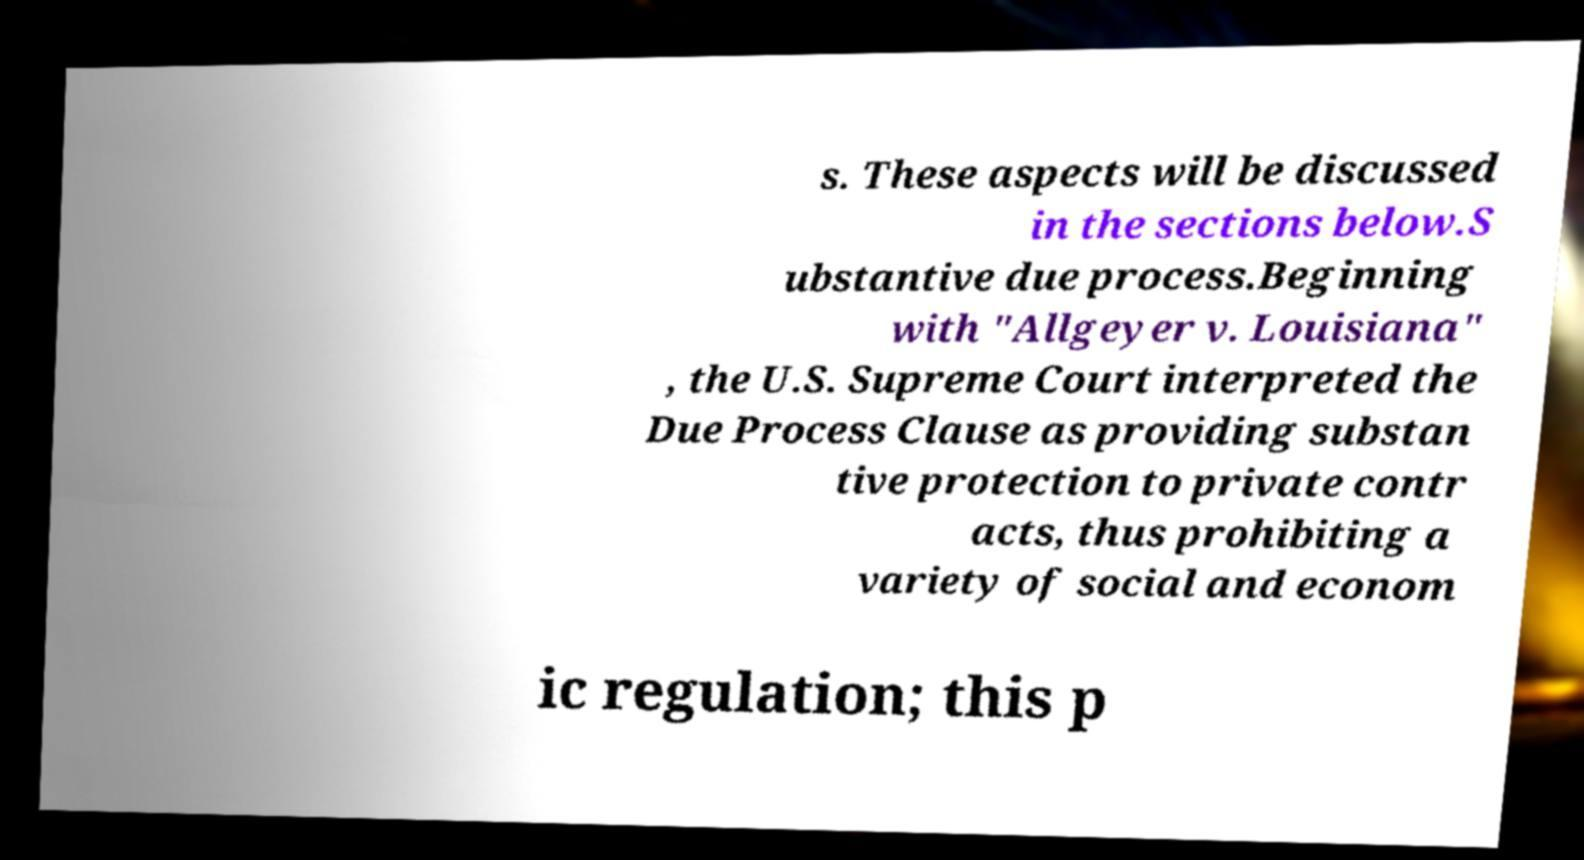Could you extract and type out the text from this image? s. These aspects will be discussed in the sections below.S ubstantive due process.Beginning with "Allgeyer v. Louisiana" , the U.S. Supreme Court interpreted the Due Process Clause as providing substan tive protection to private contr acts, thus prohibiting a variety of social and econom ic regulation; this p 